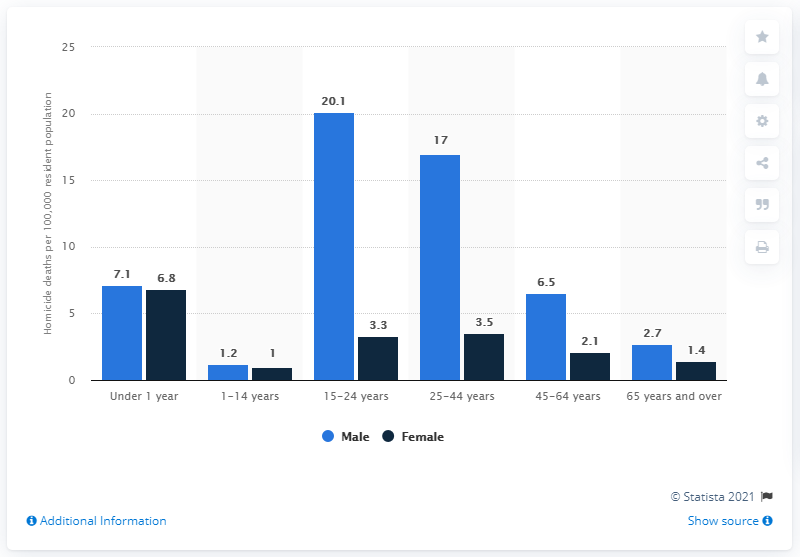Point out several critical features in this image. In the age group of 65 and over, there were 2.7 male deaths per 100,000 residents reported in the United States in 2016. 